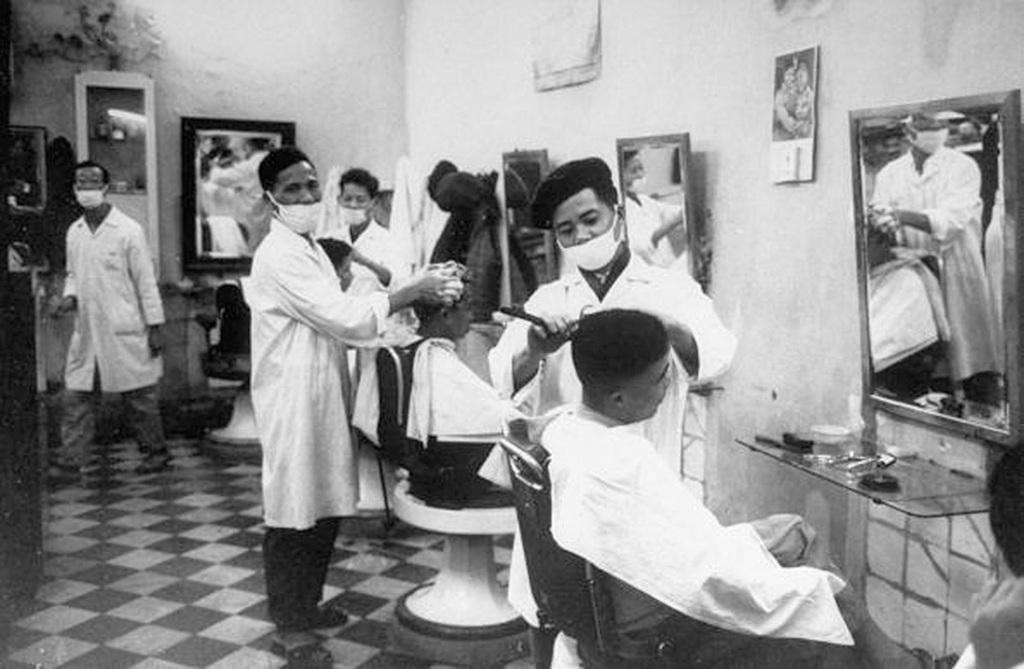In one or two sentences, can you explain what this image depicts? This is of a black and white image. I can see a group of people standing and some people are sitting on the chair. It looks like a barber shop. There are mirrors attached to the wall. This is a glass desk where some objects are placed on it. There are some photo frames which are attached to the wall. 